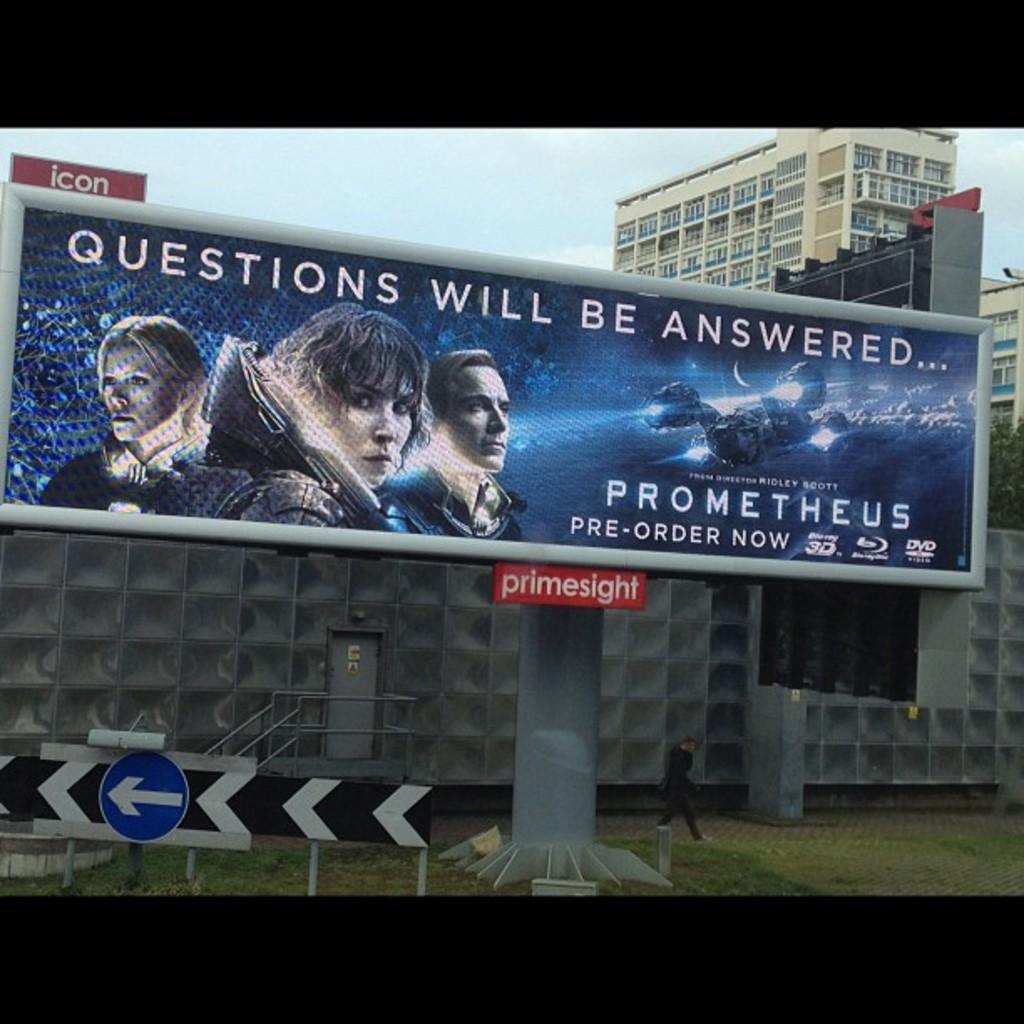<image>
Present a compact description of the photo's key features. In the new release of Prometheus, all of your questions will be answered. 